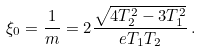<formula> <loc_0><loc_0><loc_500><loc_500>\xi _ { 0 } = \frac { 1 } { m } = 2 \frac { \sqrt { 4 T _ { 2 } ^ { 2 } - 3 T _ { 1 } ^ { 2 } } } { e T _ { 1 } T _ { 2 } } \, .</formula> 